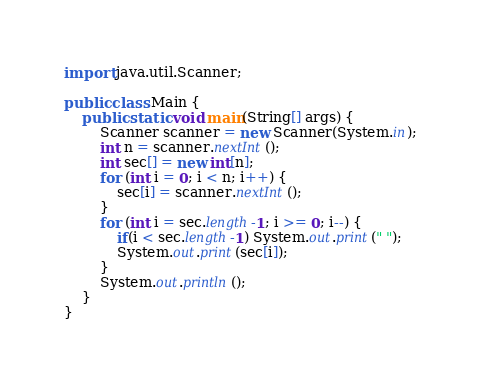<code> <loc_0><loc_0><loc_500><loc_500><_Java_>import java.util.Scanner;

public class Main {
    public static void main(String[] args) {
        Scanner scanner = new Scanner(System.in);
        int n = scanner.nextInt();
        int sec[] = new int[n];
        for (int i = 0; i < n; i++) {
            sec[i] = scanner.nextInt();
        }
        for (int i = sec.length-1; i >= 0; i--) {
            if(i < sec.length-1) System.out.print(" ");
            System.out.print(sec[i]);
        }
        System.out.println();
    }
}
</code> 